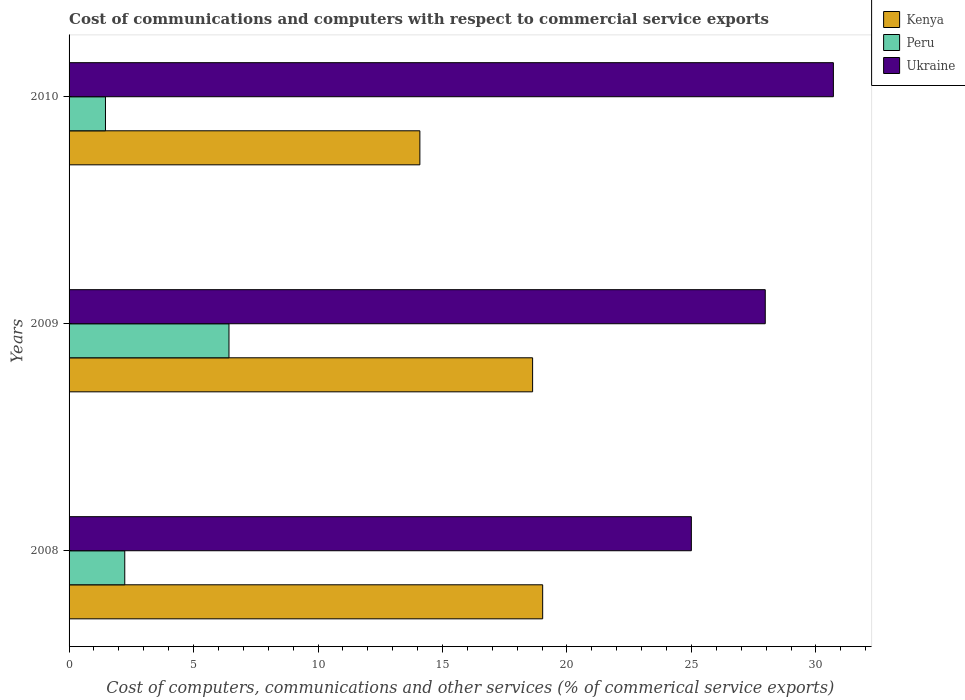How many groups of bars are there?
Make the answer very short. 3. Are the number of bars on each tick of the Y-axis equal?
Make the answer very short. Yes. How many bars are there on the 3rd tick from the top?
Provide a succinct answer. 3. What is the cost of communications and computers in Ukraine in 2008?
Give a very brief answer. 25. Across all years, what is the maximum cost of communications and computers in Peru?
Give a very brief answer. 6.42. Across all years, what is the minimum cost of communications and computers in Ukraine?
Ensure brevity in your answer.  25. In which year was the cost of communications and computers in Kenya minimum?
Offer a very short reply. 2010. What is the total cost of communications and computers in Peru in the graph?
Ensure brevity in your answer.  10.12. What is the difference between the cost of communications and computers in Ukraine in 2008 and that in 2010?
Provide a short and direct response. -5.71. What is the difference between the cost of communications and computers in Peru in 2010 and the cost of communications and computers in Kenya in 2009?
Your answer should be very brief. -17.16. What is the average cost of communications and computers in Ukraine per year?
Offer a very short reply. 27.89. In the year 2010, what is the difference between the cost of communications and computers in Peru and cost of communications and computers in Ukraine?
Offer a very short reply. -29.24. In how many years, is the cost of communications and computers in Peru greater than 14 %?
Give a very brief answer. 0. What is the ratio of the cost of communications and computers in Ukraine in 2009 to that in 2010?
Your response must be concise. 0.91. Is the cost of communications and computers in Peru in 2009 less than that in 2010?
Offer a terse response. No. Is the difference between the cost of communications and computers in Peru in 2008 and 2009 greater than the difference between the cost of communications and computers in Ukraine in 2008 and 2009?
Keep it short and to the point. No. What is the difference between the highest and the second highest cost of communications and computers in Peru?
Provide a short and direct response. 4.19. What is the difference between the highest and the lowest cost of communications and computers in Peru?
Your answer should be compact. 4.96. In how many years, is the cost of communications and computers in Kenya greater than the average cost of communications and computers in Kenya taken over all years?
Provide a short and direct response. 2. Is the sum of the cost of communications and computers in Kenya in 2008 and 2010 greater than the maximum cost of communications and computers in Peru across all years?
Your response must be concise. Yes. What does the 3rd bar from the top in 2009 represents?
Ensure brevity in your answer.  Kenya. What does the 1st bar from the bottom in 2010 represents?
Offer a very short reply. Kenya. How many bars are there?
Offer a terse response. 9. How many years are there in the graph?
Provide a short and direct response. 3. Does the graph contain grids?
Make the answer very short. No. Where does the legend appear in the graph?
Offer a terse response. Top right. How are the legend labels stacked?
Offer a very short reply. Vertical. What is the title of the graph?
Keep it short and to the point. Cost of communications and computers with respect to commercial service exports. What is the label or title of the X-axis?
Your answer should be compact. Cost of computers, communications and other services (% of commerical service exports). What is the Cost of computers, communications and other services (% of commerical service exports) in Kenya in 2008?
Ensure brevity in your answer.  19.02. What is the Cost of computers, communications and other services (% of commerical service exports) of Peru in 2008?
Keep it short and to the point. 2.24. What is the Cost of computers, communications and other services (% of commerical service exports) in Ukraine in 2008?
Your response must be concise. 25. What is the Cost of computers, communications and other services (% of commerical service exports) in Kenya in 2009?
Offer a very short reply. 18.62. What is the Cost of computers, communications and other services (% of commerical service exports) of Peru in 2009?
Keep it short and to the point. 6.42. What is the Cost of computers, communications and other services (% of commerical service exports) of Ukraine in 2009?
Keep it short and to the point. 27.96. What is the Cost of computers, communications and other services (% of commerical service exports) of Kenya in 2010?
Offer a very short reply. 14.09. What is the Cost of computers, communications and other services (% of commerical service exports) in Peru in 2010?
Give a very brief answer. 1.46. What is the Cost of computers, communications and other services (% of commerical service exports) in Ukraine in 2010?
Your response must be concise. 30.7. Across all years, what is the maximum Cost of computers, communications and other services (% of commerical service exports) of Kenya?
Provide a succinct answer. 19.02. Across all years, what is the maximum Cost of computers, communications and other services (% of commerical service exports) in Peru?
Your response must be concise. 6.42. Across all years, what is the maximum Cost of computers, communications and other services (% of commerical service exports) of Ukraine?
Your answer should be very brief. 30.7. Across all years, what is the minimum Cost of computers, communications and other services (% of commerical service exports) in Kenya?
Ensure brevity in your answer.  14.09. Across all years, what is the minimum Cost of computers, communications and other services (% of commerical service exports) in Peru?
Keep it short and to the point. 1.46. Across all years, what is the minimum Cost of computers, communications and other services (% of commerical service exports) in Ukraine?
Provide a short and direct response. 25. What is the total Cost of computers, communications and other services (% of commerical service exports) of Kenya in the graph?
Your answer should be compact. 51.73. What is the total Cost of computers, communications and other services (% of commerical service exports) in Peru in the graph?
Your response must be concise. 10.12. What is the total Cost of computers, communications and other services (% of commerical service exports) of Ukraine in the graph?
Your answer should be compact. 83.66. What is the difference between the Cost of computers, communications and other services (% of commerical service exports) of Kenya in 2008 and that in 2009?
Your response must be concise. 0.4. What is the difference between the Cost of computers, communications and other services (% of commerical service exports) of Peru in 2008 and that in 2009?
Offer a terse response. -4.19. What is the difference between the Cost of computers, communications and other services (% of commerical service exports) in Ukraine in 2008 and that in 2009?
Ensure brevity in your answer.  -2.97. What is the difference between the Cost of computers, communications and other services (% of commerical service exports) of Kenya in 2008 and that in 2010?
Your answer should be very brief. 4.93. What is the difference between the Cost of computers, communications and other services (% of commerical service exports) of Peru in 2008 and that in 2010?
Keep it short and to the point. 0.78. What is the difference between the Cost of computers, communications and other services (% of commerical service exports) of Ukraine in 2008 and that in 2010?
Provide a succinct answer. -5.71. What is the difference between the Cost of computers, communications and other services (% of commerical service exports) in Kenya in 2009 and that in 2010?
Provide a succinct answer. 4.53. What is the difference between the Cost of computers, communications and other services (% of commerical service exports) in Peru in 2009 and that in 2010?
Give a very brief answer. 4.96. What is the difference between the Cost of computers, communications and other services (% of commerical service exports) of Ukraine in 2009 and that in 2010?
Provide a succinct answer. -2.74. What is the difference between the Cost of computers, communications and other services (% of commerical service exports) of Kenya in 2008 and the Cost of computers, communications and other services (% of commerical service exports) of Peru in 2009?
Ensure brevity in your answer.  12.6. What is the difference between the Cost of computers, communications and other services (% of commerical service exports) in Kenya in 2008 and the Cost of computers, communications and other services (% of commerical service exports) in Ukraine in 2009?
Make the answer very short. -8.94. What is the difference between the Cost of computers, communications and other services (% of commerical service exports) of Peru in 2008 and the Cost of computers, communications and other services (% of commerical service exports) of Ukraine in 2009?
Provide a short and direct response. -25.73. What is the difference between the Cost of computers, communications and other services (% of commerical service exports) in Kenya in 2008 and the Cost of computers, communications and other services (% of commerical service exports) in Peru in 2010?
Offer a terse response. 17.56. What is the difference between the Cost of computers, communications and other services (% of commerical service exports) in Kenya in 2008 and the Cost of computers, communications and other services (% of commerical service exports) in Ukraine in 2010?
Make the answer very short. -11.68. What is the difference between the Cost of computers, communications and other services (% of commerical service exports) of Peru in 2008 and the Cost of computers, communications and other services (% of commerical service exports) of Ukraine in 2010?
Make the answer very short. -28.46. What is the difference between the Cost of computers, communications and other services (% of commerical service exports) in Kenya in 2009 and the Cost of computers, communications and other services (% of commerical service exports) in Peru in 2010?
Your response must be concise. 17.16. What is the difference between the Cost of computers, communications and other services (% of commerical service exports) of Kenya in 2009 and the Cost of computers, communications and other services (% of commerical service exports) of Ukraine in 2010?
Provide a short and direct response. -12.08. What is the difference between the Cost of computers, communications and other services (% of commerical service exports) in Peru in 2009 and the Cost of computers, communications and other services (% of commerical service exports) in Ukraine in 2010?
Offer a terse response. -24.28. What is the average Cost of computers, communications and other services (% of commerical service exports) of Kenya per year?
Your answer should be compact. 17.24. What is the average Cost of computers, communications and other services (% of commerical service exports) in Peru per year?
Your response must be concise. 3.37. What is the average Cost of computers, communications and other services (% of commerical service exports) of Ukraine per year?
Provide a short and direct response. 27.89. In the year 2008, what is the difference between the Cost of computers, communications and other services (% of commerical service exports) in Kenya and Cost of computers, communications and other services (% of commerical service exports) in Peru?
Your answer should be very brief. 16.79. In the year 2008, what is the difference between the Cost of computers, communications and other services (% of commerical service exports) in Kenya and Cost of computers, communications and other services (% of commerical service exports) in Ukraine?
Offer a terse response. -5.97. In the year 2008, what is the difference between the Cost of computers, communications and other services (% of commerical service exports) in Peru and Cost of computers, communications and other services (% of commerical service exports) in Ukraine?
Give a very brief answer. -22.76. In the year 2009, what is the difference between the Cost of computers, communications and other services (% of commerical service exports) of Kenya and Cost of computers, communications and other services (% of commerical service exports) of Peru?
Keep it short and to the point. 12.2. In the year 2009, what is the difference between the Cost of computers, communications and other services (% of commerical service exports) in Kenya and Cost of computers, communications and other services (% of commerical service exports) in Ukraine?
Keep it short and to the point. -9.35. In the year 2009, what is the difference between the Cost of computers, communications and other services (% of commerical service exports) of Peru and Cost of computers, communications and other services (% of commerical service exports) of Ukraine?
Ensure brevity in your answer.  -21.54. In the year 2010, what is the difference between the Cost of computers, communications and other services (% of commerical service exports) of Kenya and Cost of computers, communications and other services (% of commerical service exports) of Peru?
Your response must be concise. 12.63. In the year 2010, what is the difference between the Cost of computers, communications and other services (% of commerical service exports) of Kenya and Cost of computers, communications and other services (% of commerical service exports) of Ukraine?
Provide a short and direct response. -16.61. In the year 2010, what is the difference between the Cost of computers, communications and other services (% of commerical service exports) in Peru and Cost of computers, communications and other services (% of commerical service exports) in Ukraine?
Ensure brevity in your answer.  -29.24. What is the ratio of the Cost of computers, communications and other services (% of commerical service exports) of Kenya in 2008 to that in 2009?
Offer a terse response. 1.02. What is the ratio of the Cost of computers, communications and other services (% of commerical service exports) in Peru in 2008 to that in 2009?
Make the answer very short. 0.35. What is the ratio of the Cost of computers, communications and other services (% of commerical service exports) in Ukraine in 2008 to that in 2009?
Make the answer very short. 0.89. What is the ratio of the Cost of computers, communications and other services (% of commerical service exports) in Kenya in 2008 to that in 2010?
Offer a very short reply. 1.35. What is the ratio of the Cost of computers, communications and other services (% of commerical service exports) in Peru in 2008 to that in 2010?
Make the answer very short. 1.53. What is the ratio of the Cost of computers, communications and other services (% of commerical service exports) of Ukraine in 2008 to that in 2010?
Provide a succinct answer. 0.81. What is the ratio of the Cost of computers, communications and other services (% of commerical service exports) in Kenya in 2009 to that in 2010?
Give a very brief answer. 1.32. What is the ratio of the Cost of computers, communications and other services (% of commerical service exports) of Peru in 2009 to that in 2010?
Provide a succinct answer. 4.39. What is the ratio of the Cost of computers, communications and other services (% of commerical service exports) in Ukraine in 2009 to that in 2010?
Provide a short and direct response. 0.91. What is the difference between the highest and the second highest Cost of computers, communications and other services (% of commerical service exports) in Kenya?
Your answer should be very brief. 0.4. What is the difference between the highest and the second highest Cost of computers, communications and other services (% of commerical service exports) in Peru?
Offer a very short reply. 4.19. What is the difference between the highest and the second highest Cost of computers, communications and other services (% of commerical service exports) in Ukraine?
Offer a very short reply. 2.74. What is the difference between the highest and the lowest Cost of computers, communications and other services (% of commerical service exports) of Kenya?
Your answer should be very brief. 4.93. What is the difference between the highest and the lowest Cost of computers, communications and other services (% of commerical service exports) of Peru?
Give a very brief answer. 4.96. What is the difference between the highest and the lowest Cost of computers, communications and other services (% of commerical service exports) in Ukraine?
Provide a succinct answer. 5.71. 